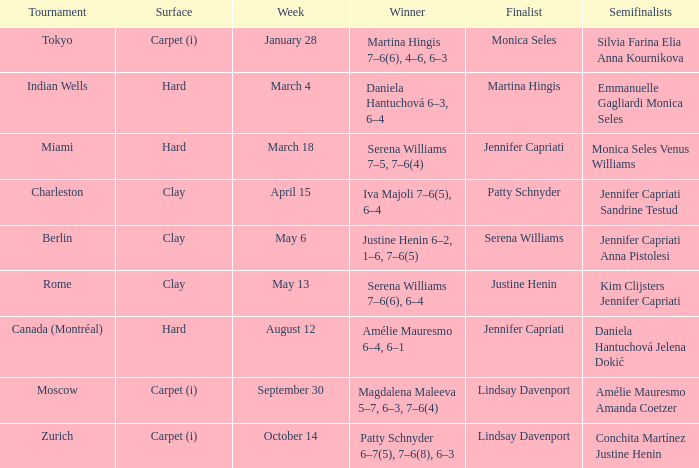Could you parse the entire table? {'header': ['Tournament', 'Surface', 'Week', 'Winner', 'Finalist', 'Semifinalists'], 'rows': [['Tokyo', 'Carpet (i)', 'January 28', 'Martina Hingis 7–6(6), 4–6, 6–3', 'Monica Seles', 'Silvia Farina Elia Anna Kournikova'], ['Indian Wells', 'Hard', 'March 4', 'Daniela Hantuchová 6–3, 6–4', 'Martina Hingis', 'Emmanuelle Gagliardi Monica Seles'], ['Miami', 'Hard', 'March 18', 'Serena Williams 7–5, 7–6(4)', 'Jennifer Capriati', 'Monica Seles Venus Williams'], ['Charleston', 'Clay', 'April 15', 'Iva Majoli 7–6(5), 6–4', 'Patty Schnyder', 'Jennifer Capriati Sandrine Testud'], ['Berlin', 'Clay', 'May 6', 'Justine Henin 6–2, 1–6, 7–6(5)', 'Serena Williams', 'Jennifer Capriati Anna Pistolesi'], ['Rome', 'Clay', 'May 13', 'Serena Williams 7–6(6), 6–4', 'Justine Henin', 'Kim Clijsters Jennifer Capriati'], ['Canada (Montréal)', 'Hard', 'August 12', 'Amélie Mauresmo 6–4, 6–1', 'Jennifer Capriati', 'Daniela Hantuchová Jelena Dokić'], ['Moscow', 'Carpet (i)', 'September 30', 'Magdalena Maleeva 5–7, 6–3, 7–6(4)', 'Lindsay Davenport', 'Amélie Mauresmo Amanda Coetzer'], ['Zurich', 'Carpet (i)', 'October 14', 'Patty Schnyder 6–7(5), 7–6(8), 6–3', 'Lindsay Davenport', 'Conchita Martínez Justine Henin']]} What tournament had finalist Monica Seles? Tokyo. 